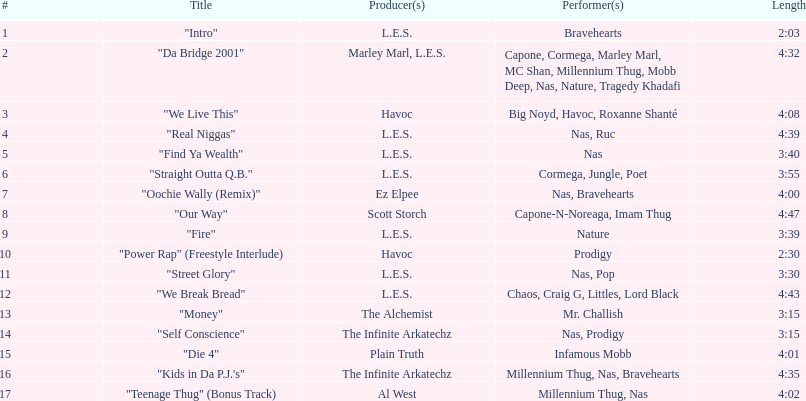Who created the last track on the album as its producer? Al West. 